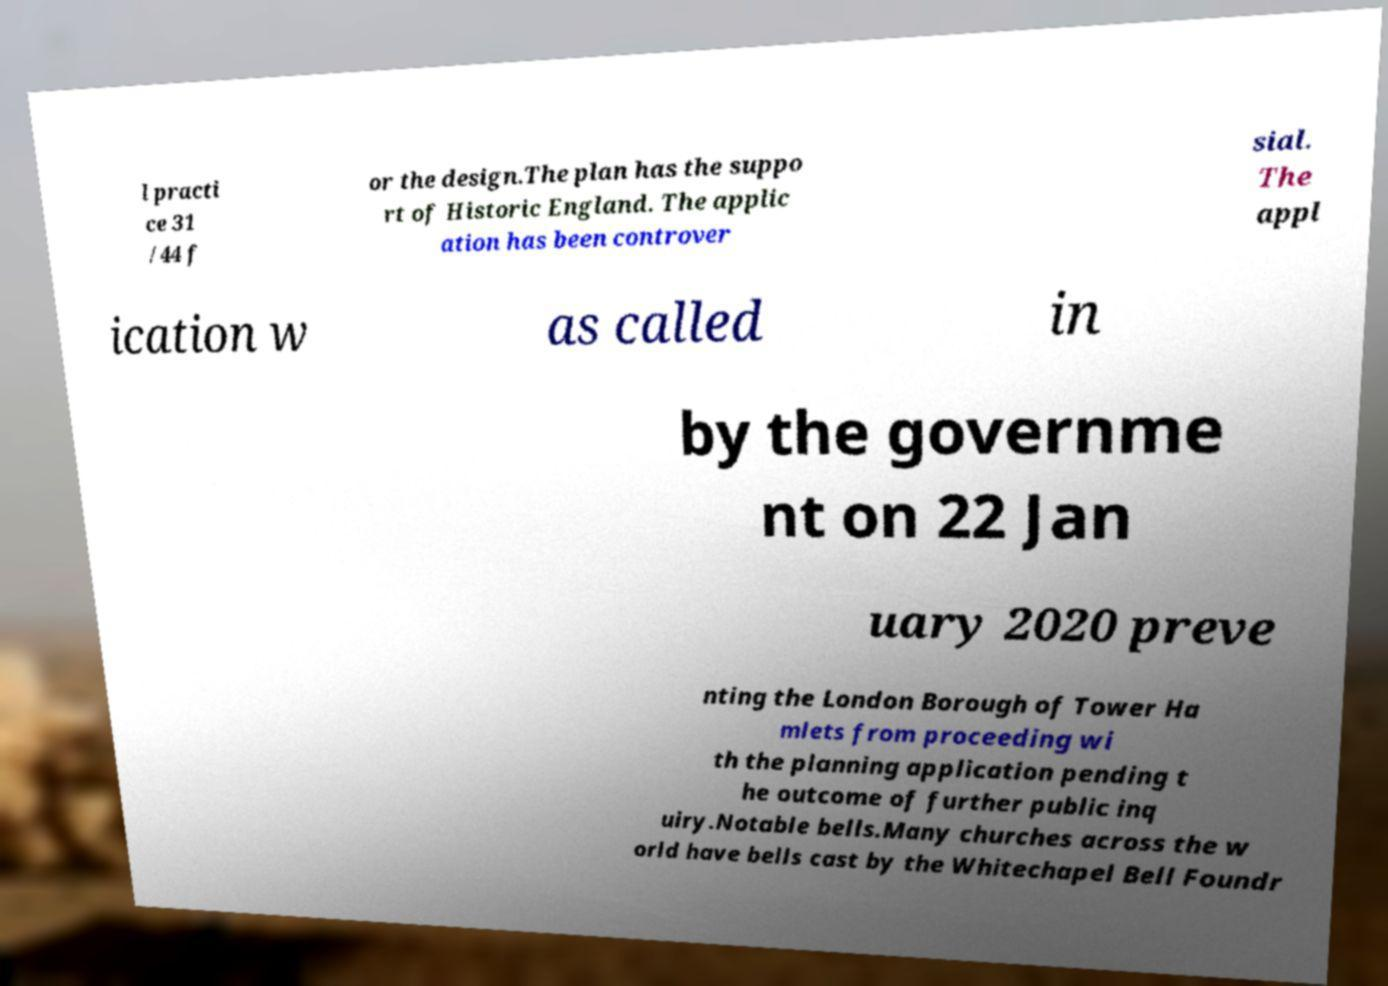What messages or text are displayed in this image? I need them in a readable, typed format. l practi ce 31 /44 f or the design.The plan has the suppo rt of Historic England. The applic ation has been controver sial. The appl ication w as called in by the governme nt on 22 Jan uary 2020 preve nting the London Borough of Tower Ha mlets from proceeding wi th the planning application pending t he outcome of further public inq uiry.Notable bells.Many churches across the w orld have bells cast by the Whitechapel Bell Foundr 